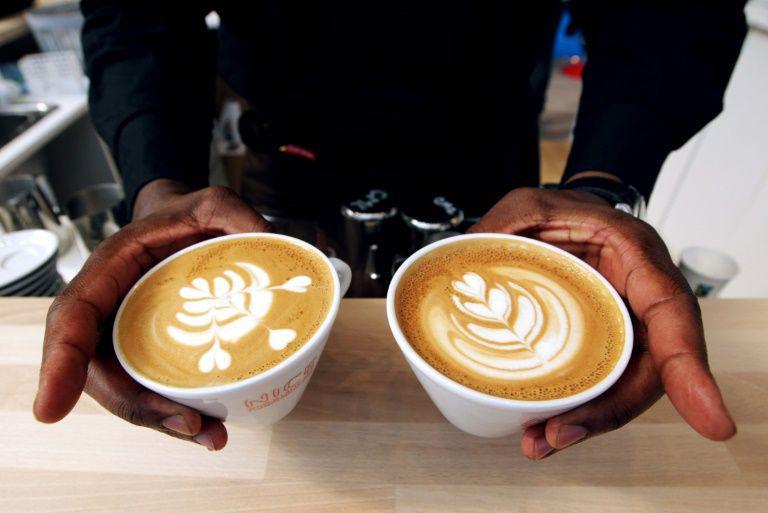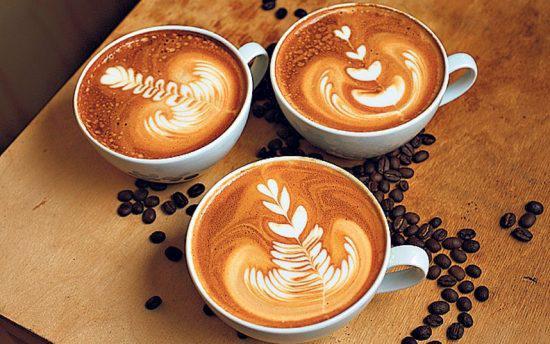The first image is the image on the left, the second image is the image on the right. Analyze the images presented: Is the assertion "All cups have patterns created by swirls of cream in a brown beverage showing at their tops." valid? Answer yes or no. Yes. The first image is the image on the left, the second image is the image on the right. For the images displayed, is the sentence "All the coffees contain milk." factually correct? Answer yes or no. Yes. 